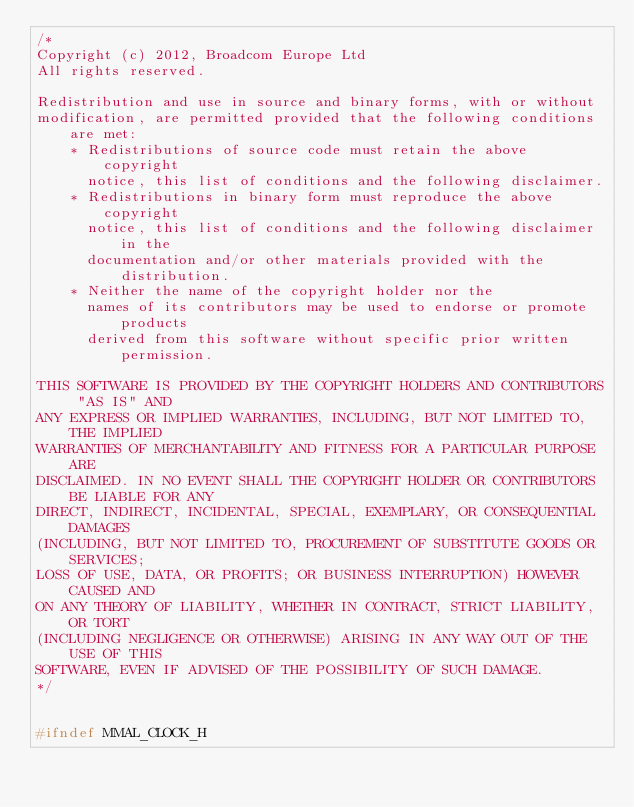<code> <loc_0><loc_0><loc_500><loc_500><_C_>/*
Copyright (c) 2012, Broadcom Europe Ltd
All rights reserved.

Redistribution and use in source and binary forms, with or without
modification, are permitted provided that the following conditions are met:
    * Redistributions of source code must retain the above copyright
      notice, this list of conditions and the following disclaimer.
    * Redistributions in binary form must reproduce the above copyright
      notice, this list of conditions and the following disclaimer in the
      documentation and/or other materials provided with the distribution.
    * Neither the name of the copyright holder nor the
      names of its contributors may be used to endorse or promote products
      derived from this software without specific prior written permission.

THIS SOFTWARE IS PROVIDED BY THE COPYRIGHT HOLDERS AND CONTRIBUTORS "AS IS" AND
ANY EXPRESS OR IMPLIED WARRANTIES, INCLUDING, BUT NOT LIMITED TO, THE IMPLIED
WARRANTIES OF MERCHANTABILITY AND FITNESS FOR A PARTICULAR PURPOSE ARE
DISCLAIMED. IN NO EVENT SHALL THE COPYRIGHT HOLDER OR CONTRIBUTORS BE LIABLE FOR ANY
DIRECT, INDIRECT, INCIDENTAL, SPECIAL, EXEMPLARY, OR CONSEQUENTIAL DAMAGES
(INCLUDING, BUT NOT LIMITED TO, PROCUREMENT OF SUBSTITUTE GOODS OR SERVICES;
LOSS OF USE, DATA, OR PROFITS; OR BUSINESS INTERRUPTION) HOWEVER CAUSED AND
ON ANY THEORY OF LIABILITY, WHETHER IN CONTRACT, STRICT LIABILITY, OR TORT
(INCLUDING NEGLIGENCE OR OTHERWISE) ARISING IN ANY WAY OUT OF THE USE OF THIS
SOFTWARE, EVEN IF ADVISED OF THE POSSIBILITY OF SUCH DAMAGE.
*/


#ifndef MMAL_CLOCK_H</code> 